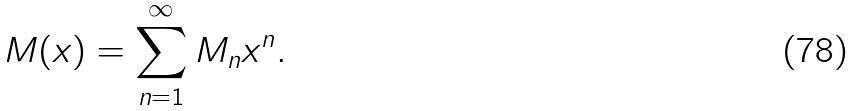Convert formula to latex. <formula><loc_0><loc_0><loc_500><loc_500>M ( x ) = \sum _ { n = 1 } ^ { \infty } M _ { n } x ^ { n } .</formula> 